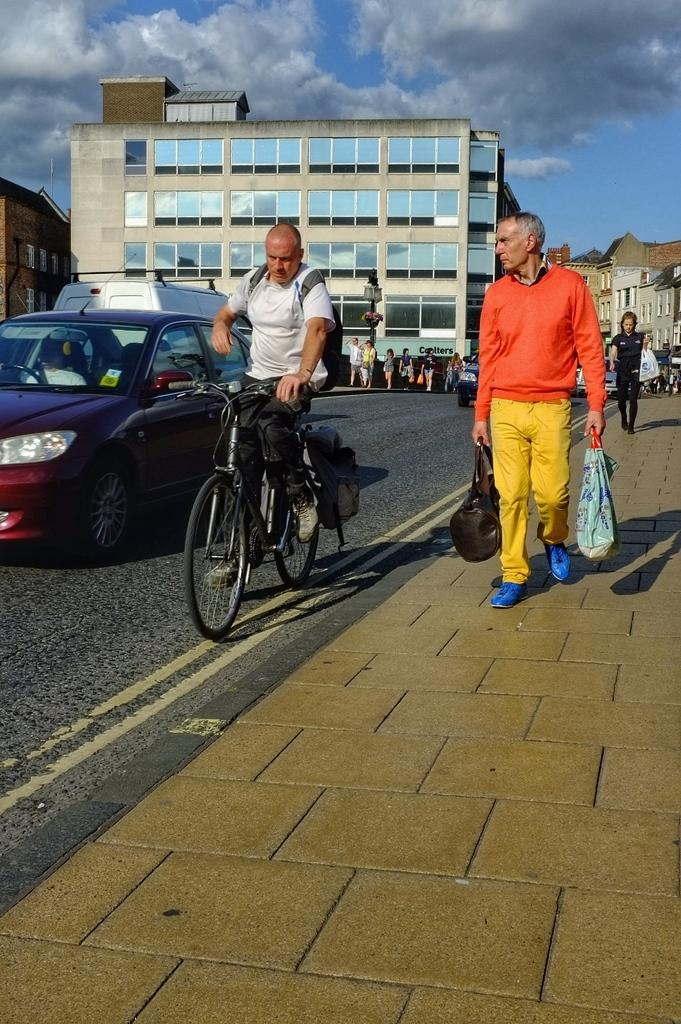What is the man in the image doing? The man is sitting on a bicycle in the image. What can be seen on the side of the road in the image? There are people standing on a footpath in the image. What is visible in the background of the image? There is a building visible in the background of the image. What type of vehicles are parked on the road in the image? Cars are parked on the road in the image. What type of butter is being used by the man on the bicycle in the image? There is no butter present in the image; the man is sitting on a bicycle. 